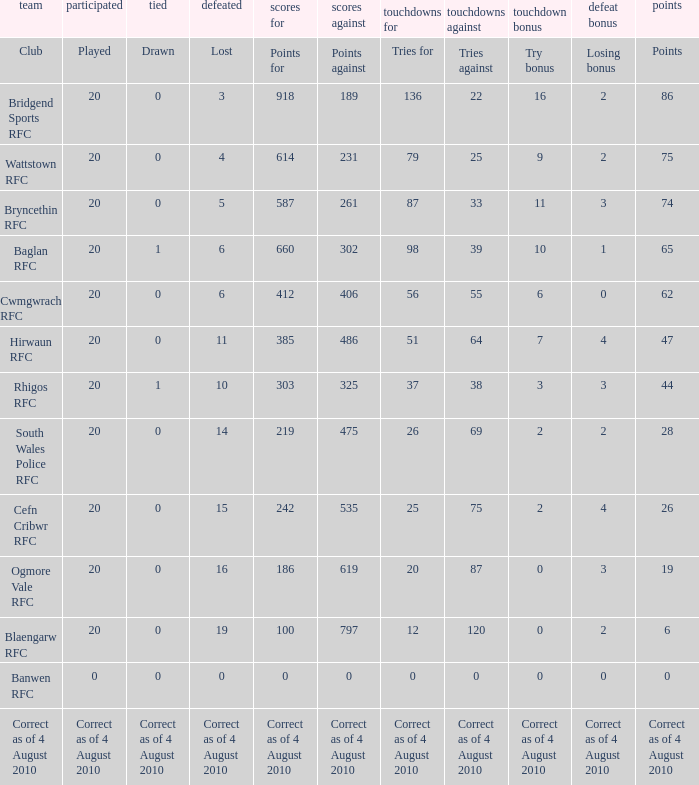What is the efforts for when losing bonus is giving up bonus? Tries for. 